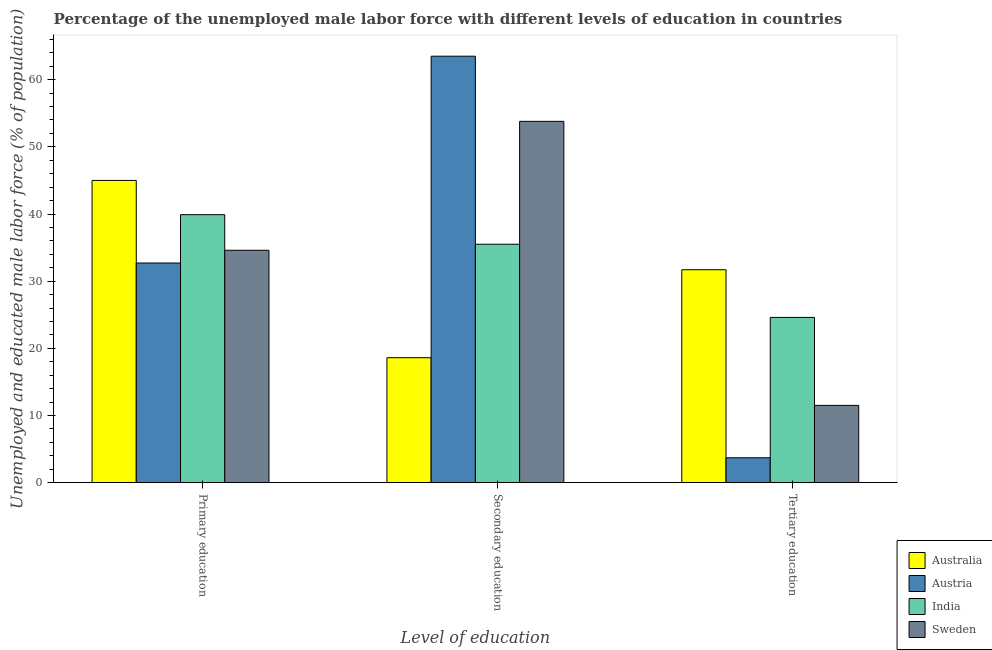How many different coloured bars are there?
Keep it short and to the point. 4. Are the number of bars per tick equal to the number of legend labels?
Provide a short and direct response. Yes. How many bars are there on the 3rd tick from the right?
Make the answer very short. 4. What is the label of the 2nd group of bars from the left?
Your answer should be very brief. Secondary education. What is the percentage of male labor force who received secondary education in India?
Offer a very short reply. 35.5. Across all countries, what is the minimum percentage of male labor force who received primary education?
Give a very brief answer. 32.7. In which country was the percentage of male labor force who received primary education maximum?
Provide a succinct answer. Australia. What is the total percentage of male labor force who received primary education in the graph?
Make the answer very short. 152.2. What is the difference between the percentage of male labor force who received secondary education in Sweden and that in Austria?
Your answer should be very brief. -9.7. What is the difference between the percentage of male labor force who received primary education in India and the percentage of male labor force who received tertiary education in Austria?
Your answer should be compact. 36.2. What is the average percentage of male labor force who received secondary education per country?
Give a very brief answer. 42.85. What is the difference between the percentage of male labor force who received secondary education and percentage of male labor force who received primary education in India?
Ensure brevity in your answer.  -4.4. In how many countries, is the percentage of male labor force who received secondary education greater than 54 %?
Offer a terse response. 1. What is the ratio of the percentage of male labor force who received tertiary education in Sweden to that in India?
Offer a very short reply. 0.47. Is the percentage of male labor force who received tertiary education in Austria less than that in Australia?
Provide a short and direct response. Yes. What is the difference between the highest and the second highest percentage of male labor force who received primary education?
Ensure brevity in your answer.  5.1. What is the difference between the highest and the lowest percentage of male labor force who received secondary education?
Your response must be concise. 44.9. Is the sum of the percentage of male labor force who received tertiary education in Sweden and Australia greater than the maximum percentage of male labor force who received secondary education across all countries?
Ensure brevity in your answer.  No. What does the 2nd bar from the right in Secondary education represents?
Keep it short and to the point. India. Is it the case that in every country, the sum of the percentage of male labor force who received primary education and percentage of male labor force who received secondary education is greater than the percentage of male labor force who received tertiary education?
Provide a succinct answer. Yes. Are all the bars in the graph horizontal?
Ensure brevity in your answer.  No. How many countries are there in the graph?
Make the answer very short. 4. Are the values on the major ticks of Y-axis written in scientific E-notation?
Keep it short and to the point. No. Does the graph contain grids?
Make the answer very short. No. Where does the legend appear in the graph?
Ensure brevity in your answer.  Bottom right. How many legend labels are there?
Ensure brevity in your answer.  4. How are the legend labels stacked?
Keep it short and to the point. Vertical. What is the title of the graph?
Provide a short and direct response. Percentage of the unemployed male labor force with different levels of education in countries. What is the label or title of the X-axis?
Keep it short and to the point. Level of education. What is the label or title of the Y-axis?
Offer a terse response. Unemployed and educated male labor force (% of population). What is the Unemployed and educated male labor force (% of population) in Australia in Primary education?
Ensure brevity in your answer.  45. What is the Unemployed and educated male labor force (% of population) in Austria in Primary education?
Offer a very short reply. 32.7. What is the Unemployed and educated male labor force (% of population) of India in Primary education?
Keep it short and to the point. 39.9. What is the Unemployed and educated male labor force (% of population) in Sweden in Primary education?
Offer a terse response. 34.6. What is the Unemployed and educated male labor force (% of population) of Australia in Secondary education?
Your answer should be compact. 18.6. What is the Unemployed and educated male labor force (% of population) in Austria in Secondary education?
Your response must be concise. 63.5. What is the Unemployed and educated male labor force (% of population) in India in Secondary education?
Your answer should be very brief. 35.5. What is the Unemployed and educated male labor force (% of population) in Sweden in Secondary education?
Your answer should be very brief. 53.8. What is the Unemployed and educated male labor force (% of population) in Australia in Tertiary education?
Give a very brief answer. 31.7. What is the Unemployed and educated male labor force (% of population) in Austria in Tertiary education?
Provide a short and direct response. 3.7. What is the Unemployed and educated male labor force (% of population) of India in Tertiary education?
Offer a terse response. 24.6. Across all Level of education, what is the maximum Unemployed and educated male labor force (% of population) in Austria?
Your response must be concise. 63.5. Across all Level of education, what is the maximum Unemployed and educated male labor force (% of population) of India?
Your response must be concise. 39.9. Across all Level of education, what is the maximum Unemployed and educated male labor force (% of population) of Sweden?
Provide a short and direct response. 53.8. Across all Level of education, what is the minimum Unemployed and educated male labor force (% of population) in Australia?
Make the answer very short. 18.6. Across all Level of education, what is the minimum Unemployed and educated male labor force (% of population) in Austria?
Ensure brevity in your answer.  3.7. Across all Level of education, what is the minimum Unemployed and educated male labor force (% of population) of India?
Provide a short and direct response. 24.6. What is the total Unemployed and educated male labor force (% of population) in Australia in the graph?
Offer a very short reply. 95.3. What is the total Unemployed and educated male labor force (% of population) of Austria in the graph?
Your answer should be compact. 99.9. What is the total Unemployed and educated male labor force (% of population) of India in the graph?
Offer a terse response. 100. What is the total Unemployed and educated male labor force (% of population) of Sweden in the graph?
Give a very brief answer. 99.9. What is the difference between the Unemployed and educated male labor force (% of population) of Australia in Primary education and that in Secondary education?
Provide a succinct answer. 26.4. What is the difference between the Unemployed and educated male labor force (% of population) of Austria in Primary education and that in Secondary education?
Provide a succinct answer. -30.8. What is the difference between the Unemployed and educated male labor force (% of population) in Sweden in Primary education and that in Secondary education?
Give a very brief answer. -19.2. What is the difference between the Unemployed and educated male labor force (% of population) in Austria in Primary education and that in Tertiary education?
Ensure brevity in your answer.  29. What is the difference between the Unemployed and educated male labor force (% of population) in India in Primary education and that in Tertiary education?
Your answer should be very brief. 15.3. What is the difference between the Unemployed and educated male labor force (% of population) of Sweden in Primary education and that in Tertiary education?
Your response must be concise. 23.1. What is the difference between the Unemployed and educated male labor force (% of population) in Australia in Secondary education and that in Tertiary education?
Provide a short and direct response. -13.1. What is the difference between the Unemployed and educated male labor force (% of population) of Austria in Secondary education and that in Tertiary education?
Give a very brief answer. 59.8. What is the difference between the Unemployed and educated male labor force (% of population) in Sweden in Secondary education and that in Tertiary education?
Your answer should be very brief. 42.3. What is the difference between the Unemployed and educated male labor force (% of population) in Australia in Primary education and the Unemployed and educated male labor force (% of population) in Austria in Secondary education?
Offer a very short reply. -18.5. What is the difference between the Unemployed and educated male labor force (% of population) in Australia in Primary education and the Unemployed and educated male labor force (% of population) in Sweden in Secondary education?
Offer a very short reply. -8.8. What is the difference between the Unemployed and educated male labor force (% of population) of Austria in Primary education and the Unemployed and educated male labor force (% of population) of India in Secondary education?
Provide a succinct answer. -2.8. What is the difference between the Unemployed and educated male labor force (% of population) in Austria in Primary education and the Unemployed and educated male labor force (% of population) in Sweden in Secondary education?
Offer a very short reply. -21.1. What is the difference between the Unemployed and educated male labor force (% of population) in Australia in Primary education and the Unemployed and educated male labor force (% of population) in Austria in Tertiary education?
Your answer should be compact. 41.3. What is the difference between the Unemployed and educated male labor force (% of population) in Australia in Primary education and the Unemployed and educated male labor force (% of population) in India in Tertiary education?
Make the answer very short. 20.4. What is the difference between the Unemployed and educated male labor force (% of population) in Australia in Primary education and the Unemployed and educated male labor force (% of population) in Sweden in Tertiary education?
Your response must be concise. 33.5. What is the difference between the Unemployed and educated male labor force (% of population) of Austria in Primary education and the Unemployed and educated male labor force (% of population) of Sweden in Tertiary education?
Provide a short and direct response. 21.2. What is the difference between the Unemployed and educated male labor force (% of population) of India in Primary education and the Unemployed and educated male labor force (% of population) of Sweden in Tertiary education?
Your response must be concise. 28.4. What is the difference between the Unemployed and educated male labor force (% of population) in Australia in Secondary education and the Unemployed and educated male labor force (% of population) in Austria in Tertiary education?
Provide a short and direct response. 14.9. What is the difference between the Unemployed and educated male labor force (% of population) of Australia in Secondary education and the Unemployed and educated male labor force (% of population) of Sweden in Tertiary education?
Make the answer very short. 7.1. What is the difference between the Unemployed and educated male labor force (% of population) of Austria in Secondary education and the Unemployed and educated male labor force (% of population) of India in Tertiary education?
Provide a short and direct response. 38.9. What is the difference between the Unemployed and educated male labor force (% of population) in Austria in Secondary education and the Unemployed and educated male labor force (% of population) in Sweden in Tertiary education?
Your response must be concise. 52. What is the average Unemployed and educated male labor force (% of population) in Australia per Level of education?
Give a very brief answer. 31.77. What is the average Unemployed and educated male labor force (% of population) in Austria per Level of education?
Keep it short and to the point. 33.3. What is the average Unemployed and educated male labor force (% of population) of India per Level of education?
Offer a very short reply. 33.33. What is the average Unemployed and educated male labor force (% of population) of Sweden per Level of education?
Keep it short and to the point. 33.3. What is the difference between the Unemployed and educated male labor force (% of population) of Austria and Unemployed and educated male labor force (% of population) of India in Primary education?
Keep it short and to the point. -7.2. What is the difference between the Unemployed and educated male labor force (% of population) in India and Unemployed and educated male labor force (% of population) in Sweden in Primary education?
Your answer should be compact. 5.3. What is the difference between the Unemployed and educated male labor force (% of population) in Australia and Unemployed and educated male labor force (% of population) in Austria in Secondary education?
Your answer should be very brief. -44.9. What is the difference between the Unemployed and educated male labor force (% of population) of Australia and Unemployed and educated male labor force (% of population) of India in Secondary education?
Your answer should be very brief. -16.9. What is the difference between the Unemployed and educated male labor force (% of population) in Australia and Unemployed and educated male labor force (% of population) in Sweden in Secondary education?
Give a very brief answer. -35.2. What is the difference between the Unemployed and educated male labor force (% of population) in India and Unemployed and educated male labor force (% of population) in Sweden in Secondary education?
Make the answer very short. -18.3. What is the difference between the Unemployed and educated male labor force (% of population) of Australia and Unemployed and educated male labor force (% of population) of Austria in Tertiary education?
Offer a very short reply. 28. What is the difference between the Unemployed and educated male labor force (% of population) of Australia and Unemployed and educated male labor force (% of population) of India in Tertiary education?
Provide a succinct answer. 7.1. What is the difference between the Unemployed and educated male labor force (% of population) in Australia and Unemployed and educated male labor force (% of population) in Sweden in Tertiary education?
Your response must be concise. 20.2. What is the difference between the Unemployed and educated male labor force (% of population) of Austria and Unemployed and educated male labor force (% of population) of India in Tertiary education?
Make the answer very short. -20.9. What is the difference between the Unemployed and educated male labor force (% of population) of Austria and Unemployed and educated male labor force (% of population) of Sweden in Tertiary education?
Your answer should be compact. -7.8. What is the ratio of the Unemployed and educated male labor force (% of population) in Australia in Primary education to that in Secondary education?
Ensure brevity in your answer.  2.42. What is the ratio of the Unemployed and educated male labor force (% of population) in Austria in Primary education to that in Secondary education?
Provide a succinct answer. 0.52. What is the ratio of the Unemployed and educated male labor force (% of population) in India in Primary education to that in Secondary education?
Offer a terse response. 1.12. What is the ratio of the Unemployed and educated male labor force (% of population) of Sweden in Primary education to that in Secondary education?
Offer a very short reply. 0.64. What is the ratio of the Unemployed and educated male labor force (% of population) of Australia in Primary education to that in Tertiary education?
Your answer should be compact. 1.42. What is the ratio of the Unemployed and educated male labor force (% of population) of Austria in Primary education to that in Tertiary education?
Give a very brief answer. 8.84. What is the ratio of the Unemployed and educated male labor force (% of population) of India in Primary education to that in Tertiary education?
Your response must be concise. 1.62. What is the ratio of the Unemployed and educated male labor force (% of population) of Sweden in Primary education to that in Tertiary education?
Keep it short and to the point. 3.01. What is the ratio of the Unemployed and educated male labor force (% of population) of Australia in Secondary education to that in Tertiary education?
Provide a short and direct response. 0.59. What is the ratio of the Unemployed and educated male labor force (% of population) in Austria in Secondary education to that in Tertiary education?
Offer a very short reply. 17.16. What is the ratio of the Unemployed and educated male labor force (% of population) of India in Secondary education to that in Tertiary education?
Offer a very short reply. 1.44. What is the ratio of the Unemployed and educated male labor force (% of population) of Sweden in Secondary education to that in Tertiary education?
Offer a terse response. 4.68. What is the difference between the highest and the second highest Unemployed and educated male labor force (% of population) in Austria?
Keep it short and to the point. 30.8. What is the difference between the highest and the second highest Unemployed and educated male labor force (% of population) in India?
Ensure brevity in your answer.  4.4. What is the difference between the highest and the second highest Unemployed and educated male labor force (% of population) in Sweden?
Offer a terse response. 19.2. What is the difference between the highest and the lowest Unemployed and educated male labor force (% of population) of Australia?
Make the answer very short. 26.4. What is the difference between the highest and the lowest Unemployed and educated male labor force (% of population) of Austria?
Provide a short and direct response. 59.8. What is the difference between the highest and the lowest Unemployed and educated male labor force (% of population) of Sweden?
Provide a short and direct response. 42.3. 